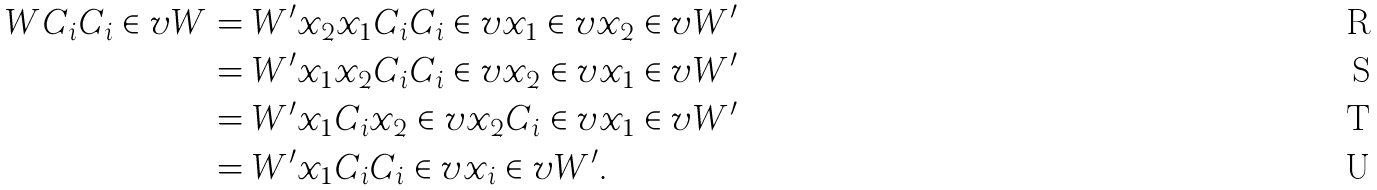<formula> <loc_0><loc_0><loc_500><loc_500>W C _ { i } C _ { i } \in v { W } & = W ^ { \prime } x _ { 2 } x _ { 1 } C _ { i } C _ { i } \in v { x _ { 1 } } \in v { x _ { 2 } } \in v { W ^ { \prime } } \quad \\ & = W ^ { \prime } x _ { 1 } x _ { 2 } C _ { i } C _ { i } \in v { x _ { 2 } } \in v { x _ { 1 } } \in v { W ^ { \prime } } \\ & = W ^ { \prime } x _ { 1 } C _ { i } x _ { 2 } \in v { x _ { 2 } } C _ { i } \in v { x _ { 1 } } \in v { W ^ { \prime } } \\ & = W ^ { \prime } x _ { 1 } C _ { i } C _ { i } \in v { x _ { i } } \in v { W ^ { \prime } } .</formula> 